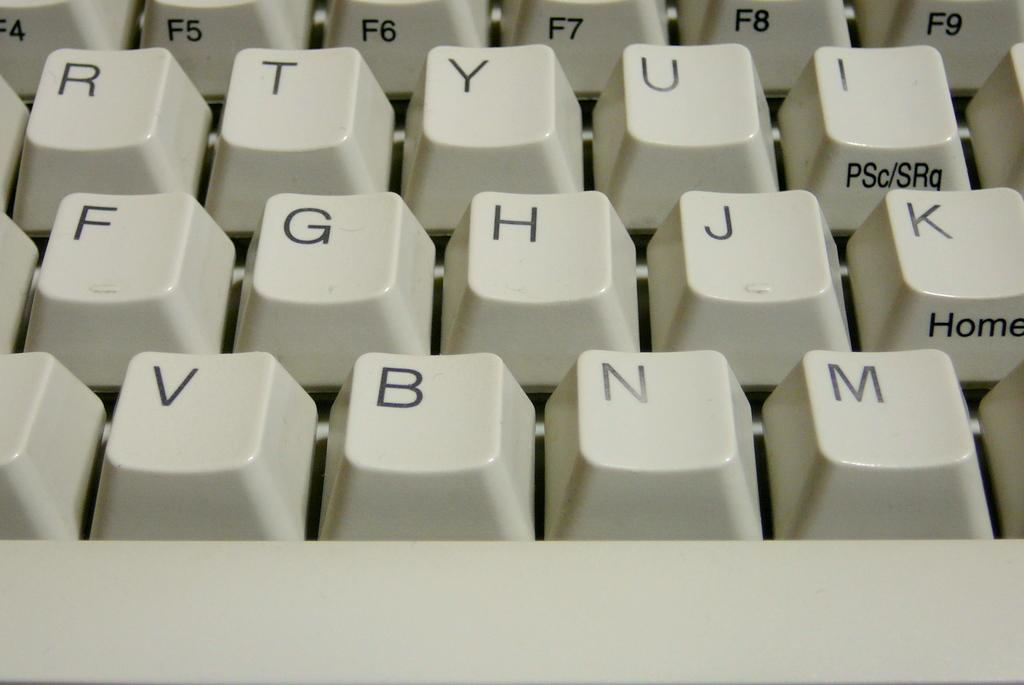<image>
Provide a brief description of the given image. a beige keyboard with letters R T H N displayed along with Home button and F8 key 